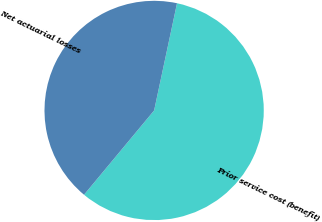Convert chart. <chart><loc_0><loc_0><loc_500><loc_500><pie_chart><fcel>Prior service cost (benefit)<fcel>Net actuarial losses<nl><fcel>57.69%<fcel>42.31%<nl></chart> 